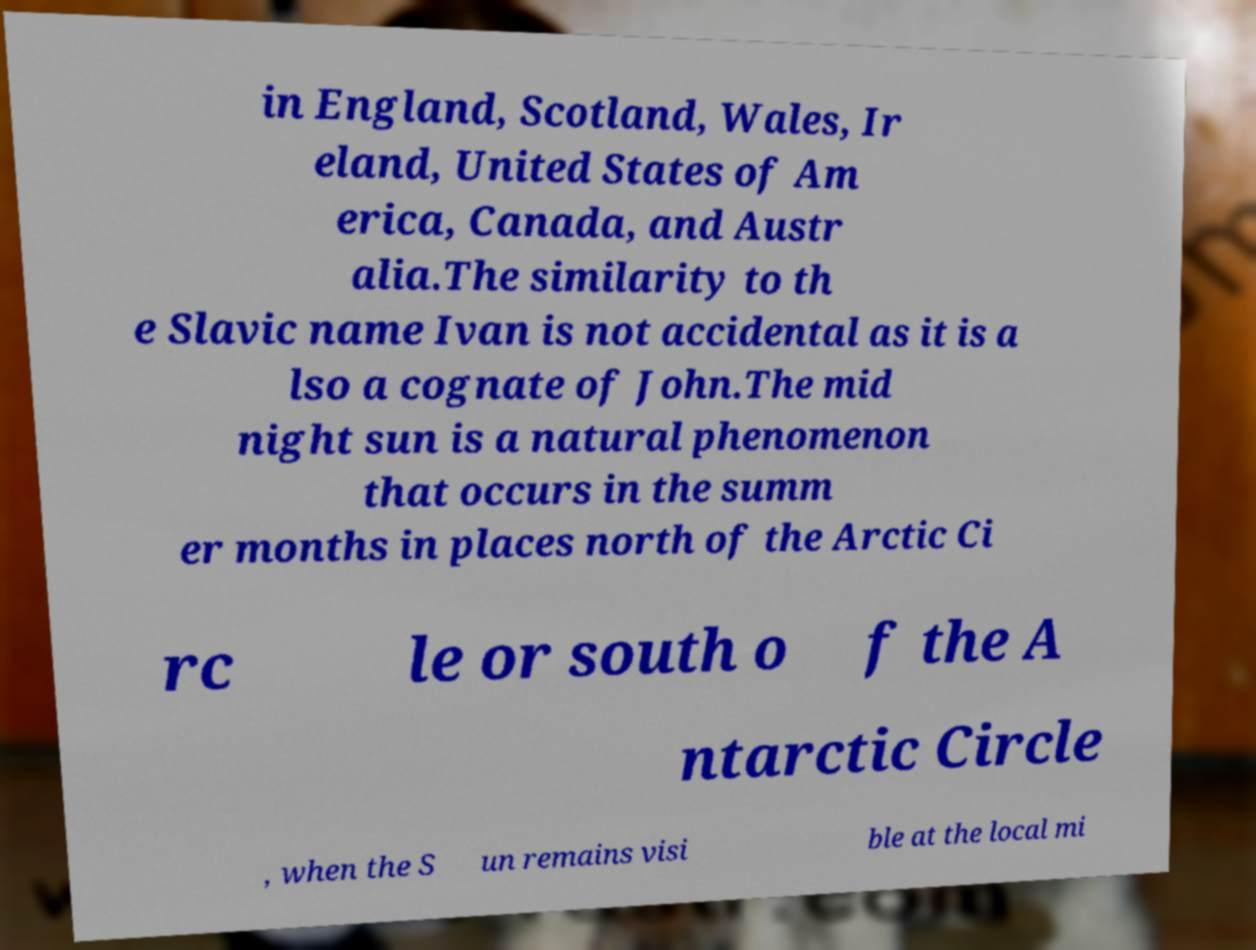There's text embedded in this image that I need extracted. Can you transcribe it verbatim? in England, Scotland, Wales, Ir eland, United States of Am erica, Canada, and Austr alia.The similarity to th e Slavic name Ivan is not accidental as it is a lso a cognate of John.The mid night sun is a natural phenomenon that occurs in the summ er months in places north of the Arctic Ci rc le or south o f the A ntarctic Circle , when the S un remains visi ble at the local mi 